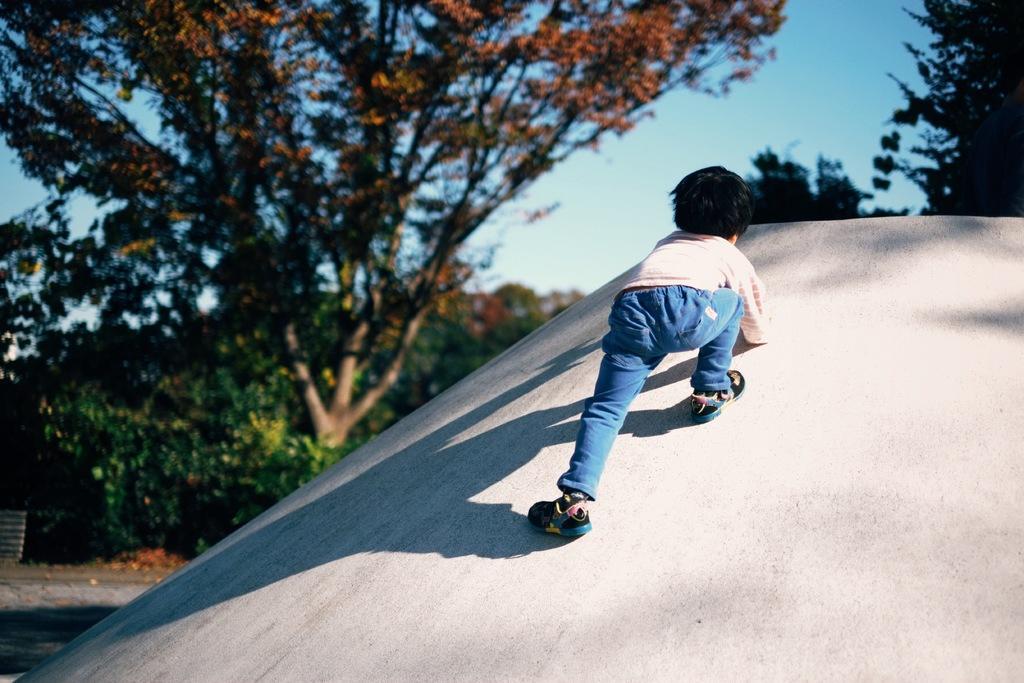Please provide a concise description of this image. In this image we can see a child climbing on a slanting surface. In the background there are trees. Also there is sky. 